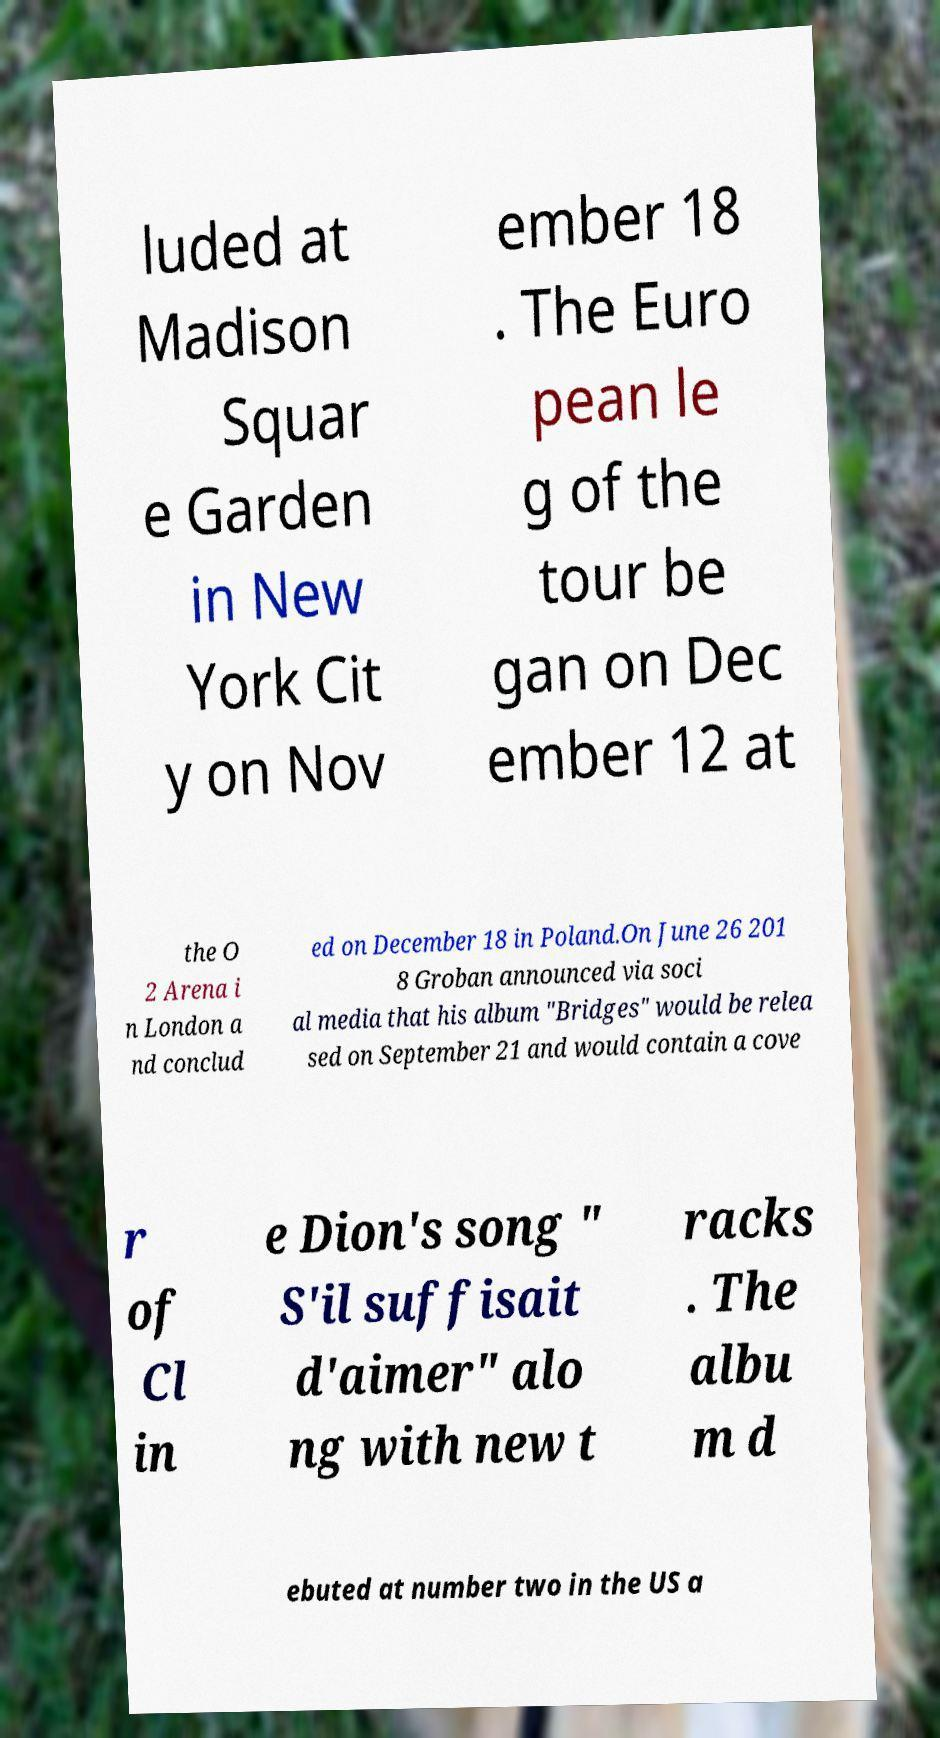Please read and relay the text visible in this image. What does it say? luded at Madison Squar e Garden in New York Cit y on Nov ember 18 . The Euro pean le g of the tour be gan on Dec ember 12 at the O 2 Arena i n London a nd conclud ed on December 18 in Poland.On June 26 201 8 Groban announced via soci al media that his album "Bridges" would be relea sed on September 21 and would contain a cove r of Cl in e Dion's song " S'il suffisait d'aimer" alo ng with new t racks . The albu m d ebuted at number two in the US a 